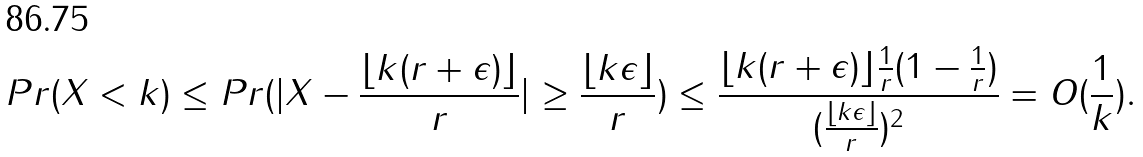Convert formula to latex. <formula><loc_0><loc_0><loc_500><loc_500>P r ( X < k ) \leq P r ( | X - \frac { \lfloor k ( r + \epsilon ) \rfloor } { r } | \geq \frac { \lfloor k \epsilon \rfloor } { r } ) \leq \frac { \lfloor k ( r + \epsilon ) \rfloor \frac { 1 } { r } ( 1 - \frac { 1 } { r } ) } { ( \frac { \lfloor k \epsilon \rfloor } { r } ) ^ { 2 } } = O ( \frac { 1 } { k } ) .</formula> 